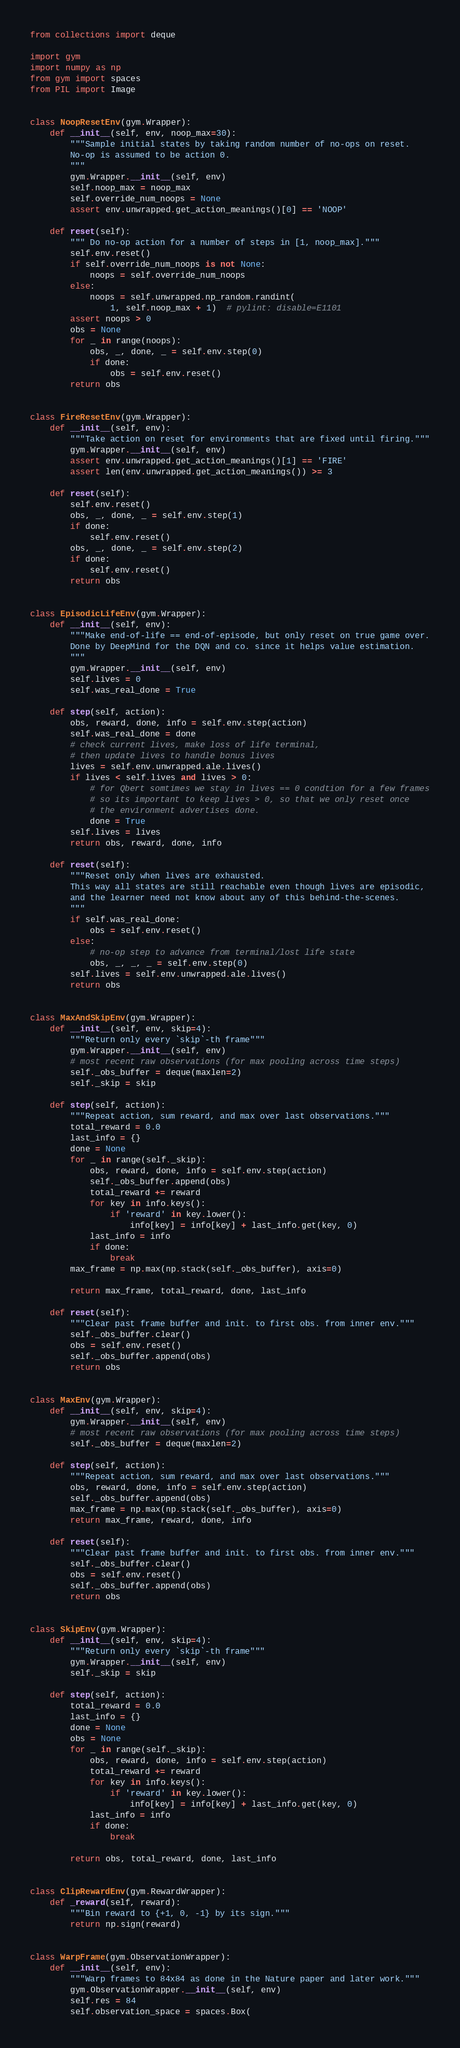<code> <loc_0><loc_0><loc_500><loc_500><_Python_>from collections import deque

import gym
import numpy as np
from gym import spaces
from PIL import Image


class NoopResetEnv(gym.Wrapper):
    def __init__(self, env, noop_max=30):
        """Sample initial states by taking random number of no-ops on reset.
        No-op is assumed to be action 0.
        """
        gym.Wrapper.__init__(self, env)
        self.noop_max = noop_max
        self.override_num_noops = None
        assert env.unwrapped.get_action_meanings()[0] == 'NOOP'

    def reset(self):
        """ Do no-op action for a number of steps in [1, noop_max]."""
        self.env.reset()
        if self.override_num_noops is not None:
            noops = self.override_num_noops
        else:
            noops = self.unwrapped.np_random.randint(
                1, self.noop_max + 1)  # pylint: disable=E1101
        assert noops > 0
        obs = None
        for _ in range(noops):
            obs, _, done, _ = self.env.step(0)
            if done:
                obs = self.env.reset()
        return obs


class FireResetEnv(gym.Wrapper):
    def __init__(self, env):
        """Take action on reset for environments that are fixed until firing."""
        gym.Wrapper.__init__(self, env)
        assert env.unwrapped.get_action_meanings()[1] == 'FIRE'
        assert len(env.unwrapped.get_action_meanings()) >= 3

    def reset(self):
        self.env.reset()
        obs, _, done, _ = self.env.step(1)
        if done:
            self.env.reset()
        obs, _, done, _ = self.env.step(2)
        if done:
            self.env.reset()
        return obs


class EpisodicLifeEnv(gym.Wrapper):
    def __init__(self, env):
        """Make end-of-life == end-of-episode, but only reset on true game over.
        Done by DeepMind for the DQN and co. since it helps value estimation.
        """
        gym.Wrapper.__init__(self, env)
        self.lives = 0
        self.was_real_done = True

    def step(self, action):
        obs, reward, done, info = self.env.step(action)
        self.was_real_done = done
        # check current lives, make loss of life terminal,
        # then update lives to handle bonus lives
        lives = self.env.unwrapped.ale.lives()
        if lives < self.lives and lives > 0:
            # for Qbert somtimes we stay in lives == 0 condtion for a few frames
            # so its important to keep lives > 0, so that we only reset once
            # the environment advertises done.
            done = True
        self.lives = lives
        return obs, reward, done, info

    def reset(self):
        """Reset only when lives are exhausted.
        This way all states are still reachable even though lives are episodic,
        and the learner need not know about any of this behind-the-scenes.
        """
        if self.was_real_done:
            obs = self.env.reset()
        else:
            # no-op step to advance from terminal/lost life state
            obs, _, _, _ = self.env.step(0)
        self.lives = self.env.unwrapped.ale.lives()
        return obs


class MaxAndSkipEnv(gym.Wrapper):
    def __init__(self, env, skip=4):
        """Return only every `skip`-th frame"""
        gym.Wrapper.__init__(self, env)
        # most recent raw observations (for max pooling across time steps)
        self._obs_buffer = deque(maxlen=2)
        self._skip = skip

    def step(self, action):
        """Repeat action, sum reward, and max over last observations."""
        total_reward = 0.0
        last_info = {}
        done = None
        for _ in range(self._skip):
            obs, reward, done, info = self.env.step(action)
            self._obs_buffer.append(obs)
            total_reward += reward
            for key in info.keys():
                if 'reward' in key.lower():
                    info[key] = info[key] + last_info.get(key, 0)
            last_info = info
            if done:
                break
        max_frame = np.max(np.stack(self._obs_buffer), axis=0)

        return max_frame, total_reward, done, last_info

    def reset(self):
        """Clear past frame buffer and init. to first obs. from inner env."""
        self._obs_buffer.clear()
        obs = self.env.reset()
        self._obs_buffer.append(obs)
        return obs


class MaxEnv(gym.Wrapper):
    def __init__(self, env, skip=4):
        gym.Wrapper.__init__(self, env)
        # most recent raw observations (for max pooling across time steps)
        self._obs_buffer = deque(maxlen=2)

    def step(self, action):
        """Repeat action, sum reward, and max over last observations."""
        obs, reward, done, info = self.env.step(action)
        self._obs_buffer.append(obs)
        max_frame = np.max(np.stack(self._obs_buffer), axis=0)
        return max_frame, reward, done, info

    def reset(self):
        """Clear past frame buffer and init. to first obs. from inner env."""
        self._obs_buffer.clear()
        obs = self.env.reset()
        self._obs_buffer.append(obs)
        return obs


class SkipEnv(gym.Wrapper):
    def __init__(self, env, skip=4):
        """Return only every `skip`-th frame"""
        gym.Wrapper.__init__(self, env)
        self._skip = skip

    def step(self, action):
        total_reward = 0.0
        last_info = {}
        done = None
        obs = None
        for _ in range(self._skip):
            obs, reward, done, info = self.env.step(action)
            total_reward += reward
            for key in info.keys():
                if 'reward' in key.lower():
                    info[key] = info[key] + last_info.get(key, 0)
            last_info = info
            if done:
                break

        return obs, total_reward, done, last_info


class ClipRewardEnv(gym.RewardWrapper):
    def _reward(self, reward):
        """Bin reward to {+1, 0, -1} by its sign."""
        return np.sign(reward)


class WarpFrame(gym.ObservationWrapper):
    def __init__(self, env):
        """Warp frames to 84x84 as done in the Nature paper and later work."""
        gym.ObservationWrapper.__init__(self, env)
        self.res = 84
        self.observation_space = spaces.Box(</code> 